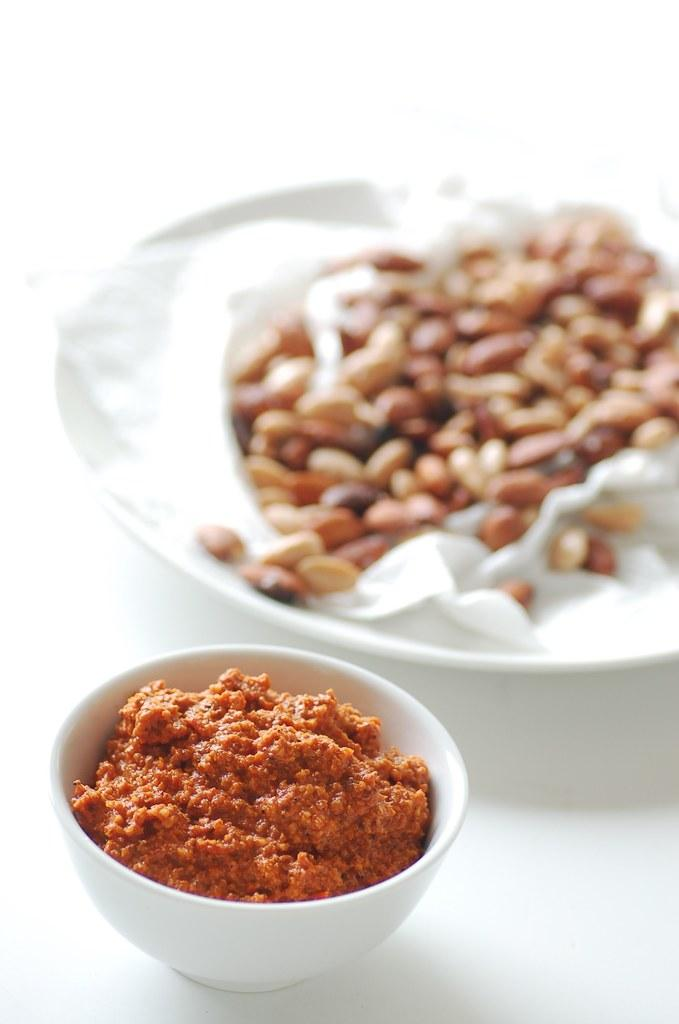What type of food is on the plate in the image? The specific type of food on the plate cannot be determined from the provided facts. What type of food is inside the white bowl in the image? The specific type of food inside the white bowl cannot be determined from the provided facts. What type of wax is being used to create the paste in the image? There is no wax or paste present in the image; it only features food on a plate and inside a white bowl. 